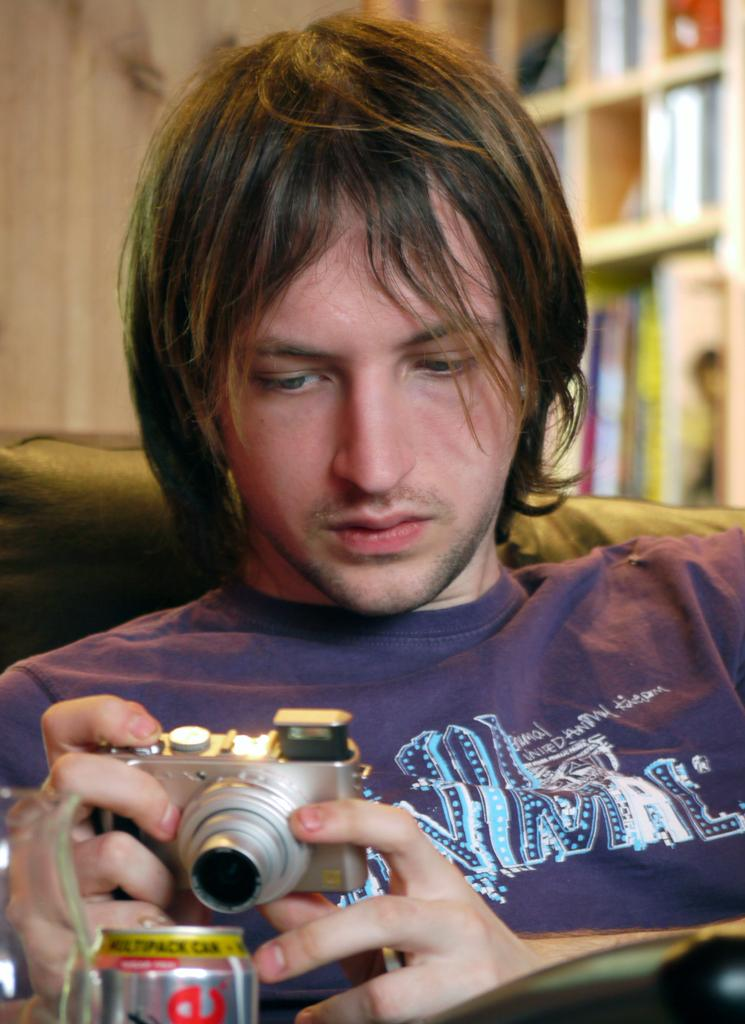What is the man in the image doing? The man is sitting on the sofa and holding a camera. What is the man taking a picture of? The man is taking a picture of a coke tin. What can be seen in the background of the image? There is a shelf with books and a wooden wall beside the shelf in the background. What type of glove is the man wearing while taking the picture? The man is not wearing any gloves in the image. Can you see any grass in the image? There is no grass visible in the image. 